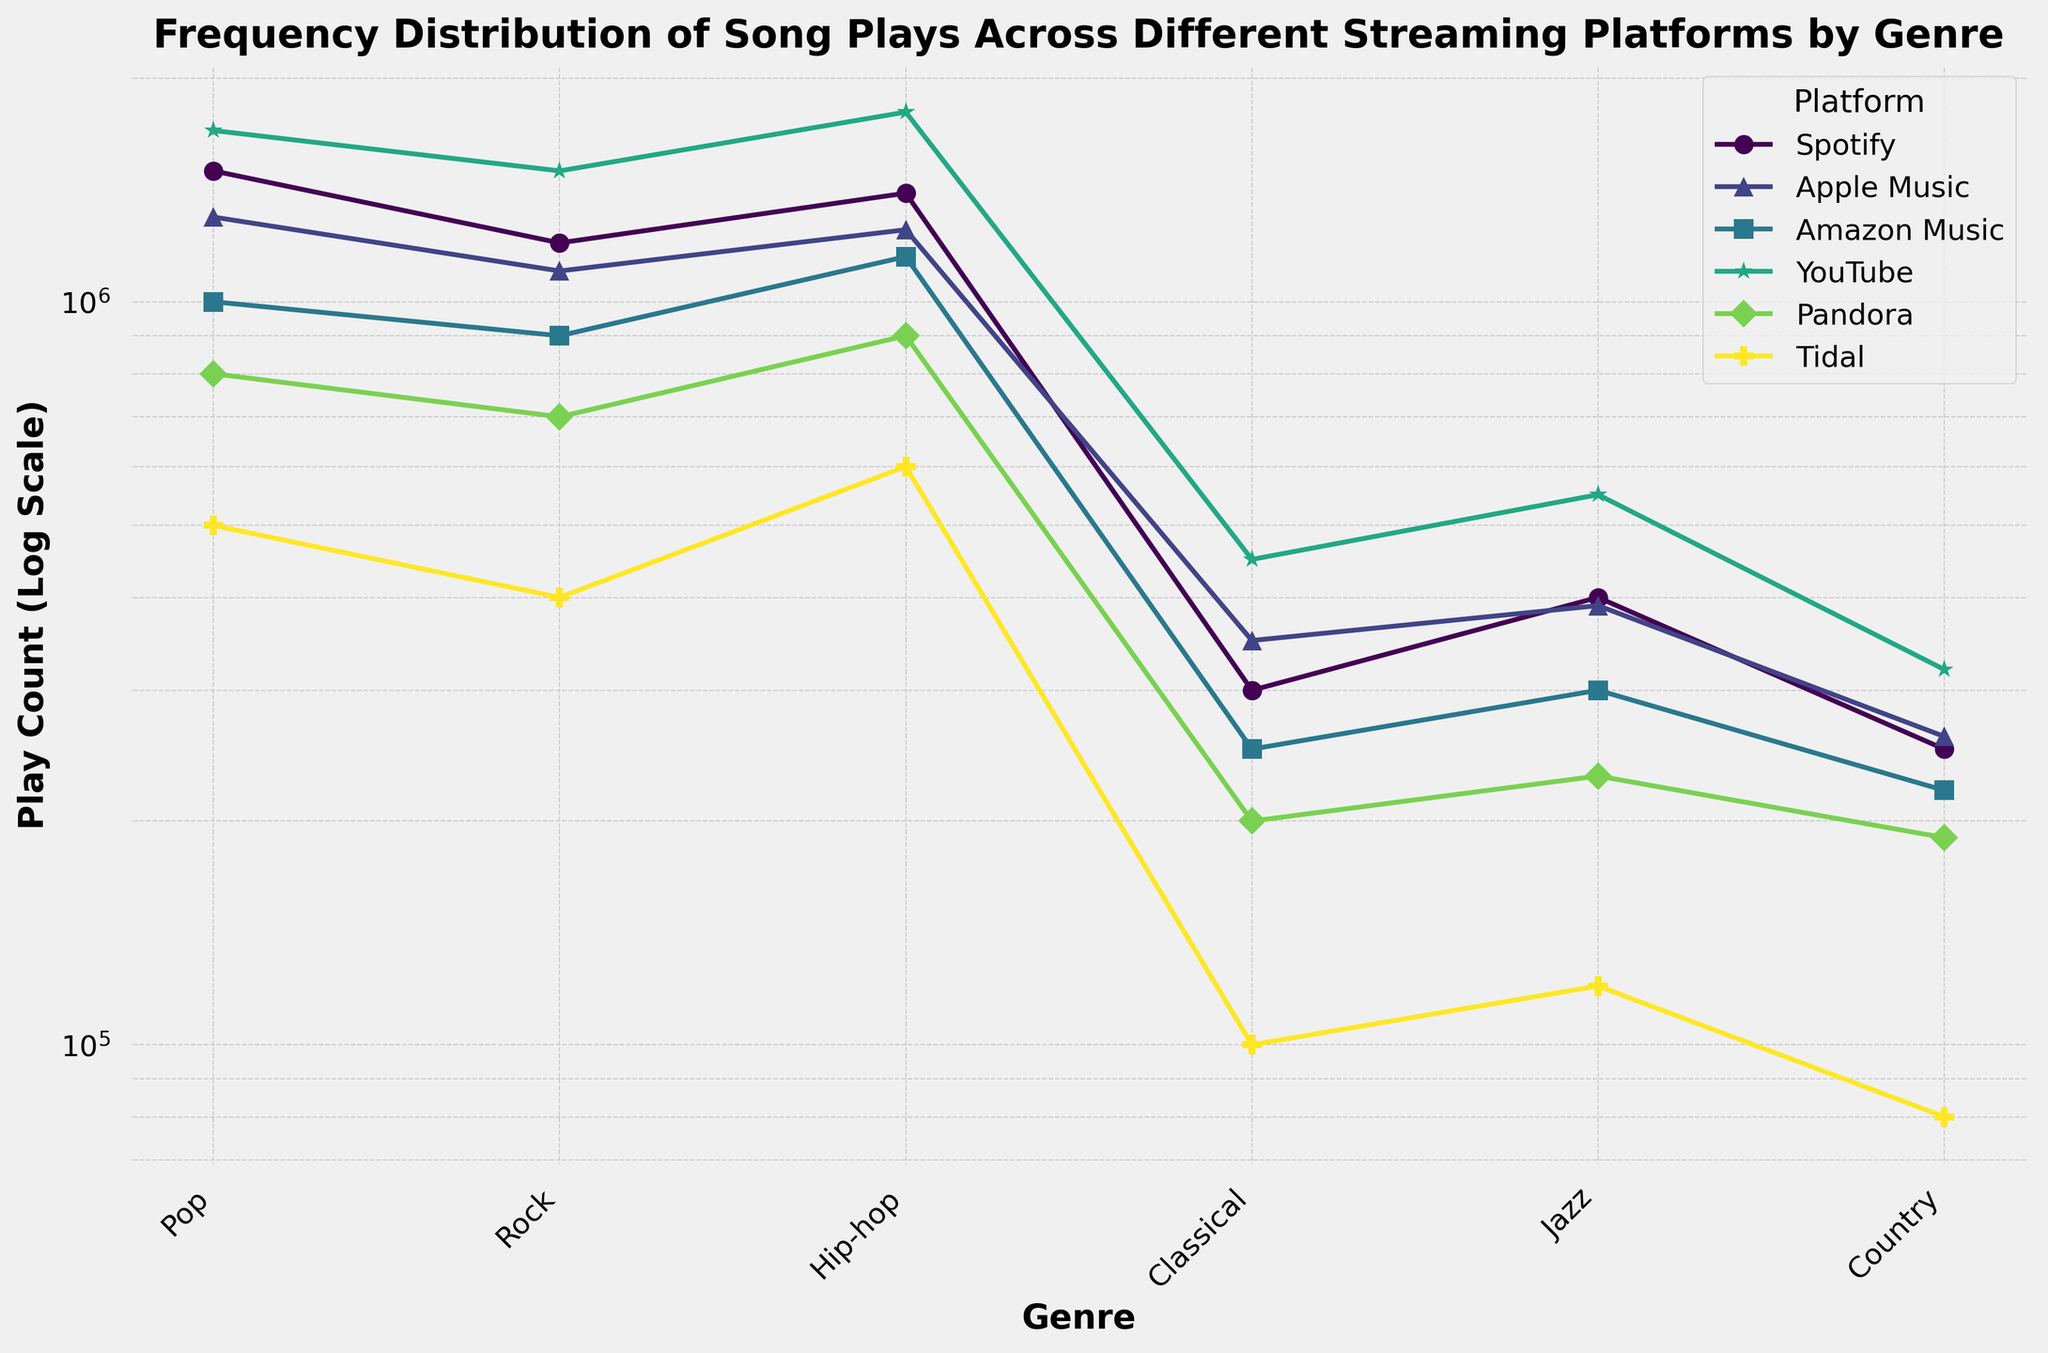What platform has the highest play count for Hip-hop? By visually inspecting the chart and looking for the highest point among the markers representing Hip-hop across different platforms, YouTube has the highest marker.
Answer: YouTube Which genres have more plays on Spotify compared to Apple Music? By comparing the heights or marker positions of genres (Pop, Rock, Hip-hop, Classical, Jazz, and Country) on Spotify and Apple Music, we see Pop and Hip-hop have higher play counts on Spotify.
Answer: Pop, Hip-hop How does the play count for Country music on YouTube compare to its play count on Spotify? Compare the markers of Country music on YouTube and Spotify. Country on YouTube has a higher marker compared to Spotify.
Answer: Higher on YouTube Which genre on Pandora has the lowest play count? Visually inspect the markers representing genres on Pandora and find the lowest one, which is Classical.
Answer: Classical What's the difference in play count for Jazz between YouTube and Tidal? Find the markers for Jazz on YouTube and Tidal, note their respective play counts, and subtract Tidal's count from YouTube's.
Answer: 430,000 Which platform shows the most significant variation in play counts across different genres? By visually comparing the range and spread of play counts (height difference between the highest and lowest markers) across all genres for each platform, YouTube shows the largest variation.
Answer: YouTube What is the combined play count for Rock and Pop genres on Amazon Music? Sum the play counts for Rock and Pop on Amazon Music: 900,000 + 1,000,000 = 1,900,000.
Answer: 1,900,000 Between Classical and Jazz on Apple Music, which genre has close play counts? Compare the markers of Classical and Jazz on Apple Music. Both genres have play counts near each other, with Classical at 350,000 and Jazz at 390,000.
Answer: Classical and Jazz On which platform does Country music have the lowest play count? Visually inspect and compare the Country music markers across all platforms. Tidal has the lowest play count marker for Country music.
Answer: Tidal What genre has the second-lowest play count on Spotify? By ranking the play counts visually for Spotify, the second-lowest play count comes for Jazz, though Country has the lowest.
Answer: Jazz 